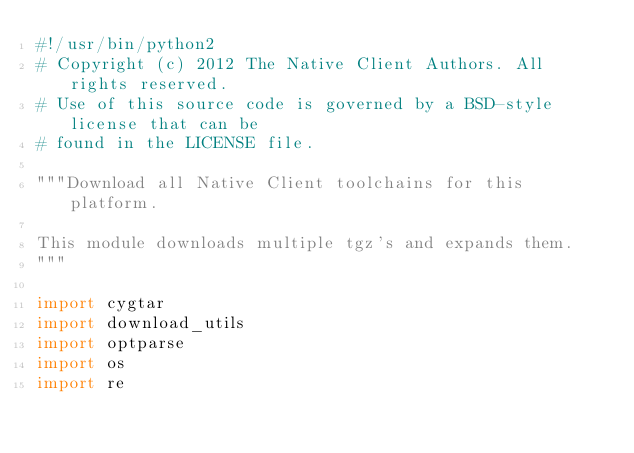Convert code to text. <code><loc_0><loc_0><loc_500><loc_500><_Python_>#!/usr/bin/python2
# Copyright (c) 2012 The Native Client Authors. All rights reserved.
# Use of this source code is governed by a BSD-style license that can be
# found in the LICENSE file.

"""Download all Native Client toolchains for this platform.

This module downloads multiple tgz's and expands them.
"""

import cygtar
import download_utils
import optparse
import os
import re</code> 